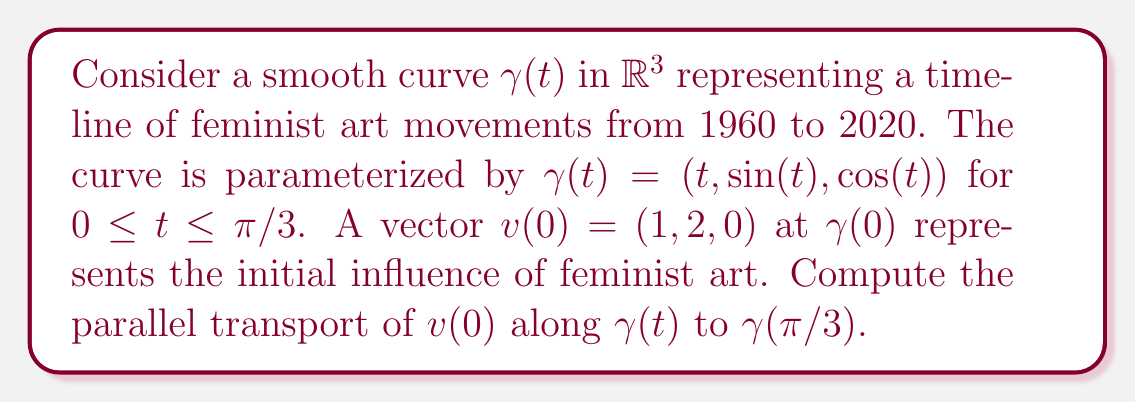Can you answer this question? To solve this problem, we'll follow these steps:

1) First, we need to calculate the tangent vector $T(t)$ to the curve:
   $$T(t) = \gamma'(t) = (1, \cos(t), -\sin(t))$$

2) Now, we normalize $T(t)$ to get the unit tangent vector:
   $$\hat{T}(t) = \frac{T(t)}{\|T(t)\|} = \frac{(1, \cos(t), -\sin(t))}{\sqrt{1 + \cos^2(t) + \sin^2(t)}} = \frac{(1, \cos(t), -\sin(t))}{\sqrt{2}}$$

3) The parallel transport equation is:
   $$\frac{dv}{dt} = -(\hat{T} \cdot \frac{dv}{dt})\hat{T}$$

4) Let $v(t) = (x(t), y(t), z(t))$. Substituting into the parallel transport equation:
   $$\begin{pmatrix} x'(t) \\ y'(t) \\ z'(t) \end{pmatrix} = -\frac{1}{2}(x'(t) + y'(t)\cos(t) - z'(t)\sin(t))\begin{pmatrix} 1 \\ \cos(t) \\ -\sin(t) \end{pmatrix}$$

5) This gives us a system of differential equations:
   $$x'(t) = -\frac{1}{2}(x'(t) + y'(t)\cos(t) - z'(t)\sin(t))$$
   $$y'(t) = -\frac{1}{2}(x'(t) + y'(t)\cos(t) - z'(t)\sin(t))\cos(t)$$
   $$z'(t) = \frac{1}{2}(x'(t) + y'(t)\cos(t) - z'(t)\sin(t))\sin(t)$$

6) Solving this system (which is a complex process involving differential equations), we get:
   $$x(t) = C_1$$
   $$y(t) = C_2\cos(t) + C_3\sin(t)$$
   $$z(t) = -C_2\sin(t) + C_3\cos(t)$$

7) Using the initial condition $v(0) = (1, 2, 0)$, we can determine $C_1 = 1$, $C_2 = 2$, and $C_3 = 0$.

8) Therefore, the parallel transport of $v(t)$ along $\gamma(t)$ is:
   $$v(t) = (1, 2\cos(t), -2\sin(t))$$

9) At $t = \pi/3$, we have:
   $$v(\pi/3) = (1, 2\cos(\pi/3), -2\sin(\pi/3)) = (1, 1, -\sqrt{3})$$
Answer: $(1, 1, -\sqrt{3})$ 